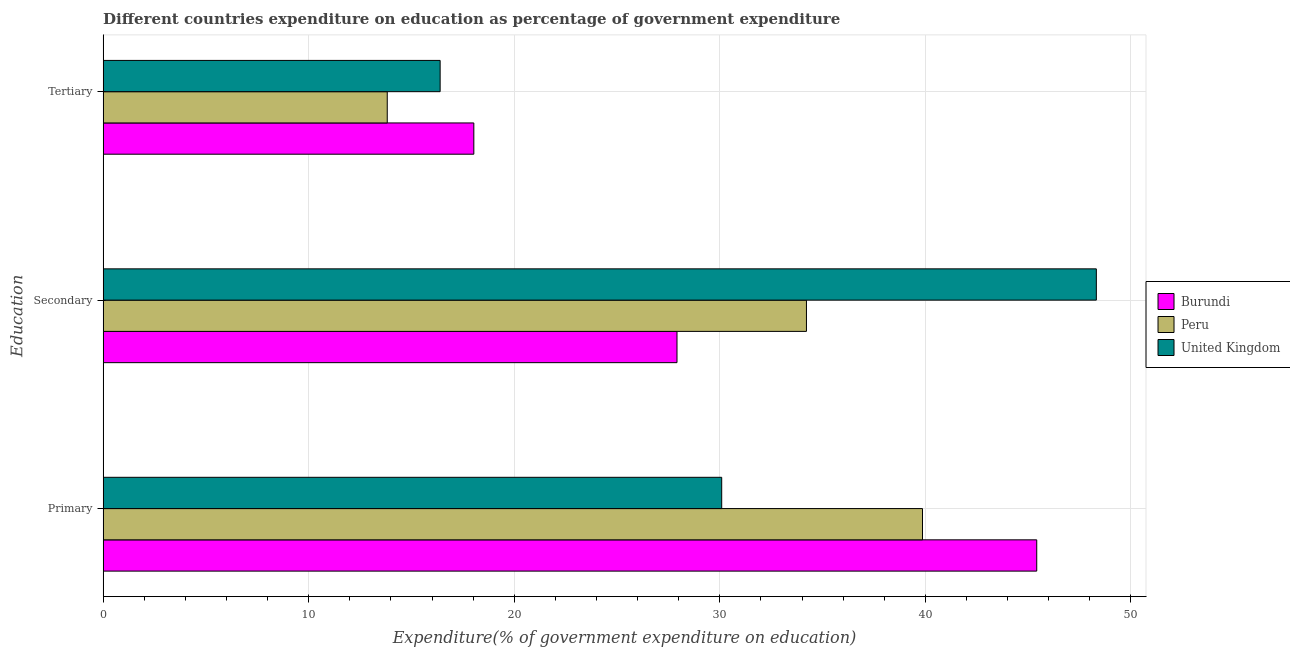How many groups of bars are there?
Your response must be concise. 3. How many bars are there on the 3rd tick from the top?
Ensure brevity in your answer.  3. What is the label of the 1st group of bars from the top?
Give a very brief answer. Tertiary. What is the expenditure on tertiary education in Burundi?
Keep it short and to the point. 18.03. Across all countries, what is the maximum expenditure on secondary education?
Your answer should be compact. 48.32. Across all countries, what is the minimum expenditure on tertiary education?
Offer a terse response. 13.82. In which country was the expenditure on primary education maximum?
Your answer should be compact. Burundi. What is the total expenditure on primary education in the graph?
Provide a succinct answer. 115.37. What is the difference between the expenditure on primary education in United Kingdom and that in Burundi?
Offer a very short reply. -15.33. What is the difference between the expenditure on secondary education in Burundi and the expenditure on primary education in Peru?
Provide a succinct answer. -11.94. What is the average expenditure on tertiary education per country?
Offer a terse response. 16.08. What is the difference between the expenditure on tertiary education and expenditure on secondary education in Burundi?
Your response must be concise. -9.88. What is the ratio of the expenditure on secondary education in Burundi to that in Peru?
Make the answer very short. 0.82. Is the expenditure on tertiary education in Burundi less than that in Peru?
Your response must be concise. No. What is the difference between the highest and the second highest expenditure on secondary education?
Offer a very short reply. 14.1. What is the difference between the highest and the lowest expenditure on primary education?
Your answer should be very brief. 15.33. What does the 1st bar from the top in Primary represents?
Offer a terse response. United Kingdom. Is it the case that in every country, the sum of the expenditure on primary education and expenditure on secondary education is greater than the expenditure on tertiary education?
Keep it short and to the point. Yes. How many bars are there?
Offer a terse response. 9. Are all the bars in the graph horizontal?
Give a very brief answer. Yes. How many countries are there in the graph?
Give a very brief answer. 3. Does the graph contain any zero values?
Make the answer very short. No. How are the legend labels stacked?
Ensure brevity in your answer.  Vertical. What is the title of the graph?
Offer a very short reply. Different countries expenditure on education as percentage of government expenditure. What is the label or title of the X-axis?
Your answer should be very brief. Expenditure(% of government expenditure on education). What is the label or title of the Y-axis?
Your answer should be very brief. Education. What is the Expenditure(% of government expenditure on education) of Burundi in Primary?
Your response must be concise. 45.42. What is the Expenditure(% of government expenditure on education) of Peru in Primary?
Your answer should be very brief. 39.86. What is the Expenditure(% of government expenditure on education) of United Kingdom in Primary?
Your answer should be very brief. 30.09. What is the Expenditure(% of government expenditure on education) in Burundi in Secondary?
Offer a terse response. 27.92. What is the Expenditure(% of government expenditure on education) in Peru in Secondary?
Offer a terse response. 34.22. What is the Expenditure(% of government expenditure on education) of United Kingdom in Secondary?
Make the answer very short. 48.32. What is the Expenditure(% of government expenditure on education) in Burundi in Tertiary?
Offer a very short reply. 18.03. What is the Expenditure(% of government expenditure on education) in Peru in Tertiary?
Give a very brief answer. 13.82. What is the Expenditure(% of government expenditure on education) of United Kingdom in Tertiary?
Provide a succinct answer. 16.39. Across all Education, what is the maximum Expenditure(% of government expenditure on education) in Burundi?
Your response must be concise. 45.42. Across all Education, what is the maximum Expenditure(% of government expenditure on education) in Peru?
Make the answer very short. 39.86. Across all Education, what is the maximum Expenditure(% of government expenditure on education) of United Kingdom?
Your answer should be compact. 48.32. Across all Education, what is the minimum Expenditure(% of government expenditure on education) of Burundi?
Provide a short and direct response. 18.03. Across all Education, what is the minimum Expenditure(% of government expenditure on education) of Peru?
Provide a short and direct response. 13.82. Across all Education, what is the minimum Expenditure(% of government expenditure on education) in United Kingdom?
Provide a succinct answer. 16.39. What is the total Expenditure(% of government expenditure on education) of Burundi in the graph?
Keep it short and to the point. 91.37. What is the total Expenditure(% of government expenditure on education) in Peru in the graph?
Provide a short and direct response. 87.9. What is the total Expenditure(% of government expenditure on education) in United Kingdom in the graph?
Give a very brief answer. 94.81. What is the difference between the Expenditure(% of government expenditure on education) in Burundi in Primary and that in Secondary?
Keep it short and to the point. 17.5. What is the difference between the Expenditure(% of government expenditure on education) of Peru in Primary and that in Secondary?
Offer a very short reply. 5.64. What is the difference between the Expenditure(% of government expenditure on education) in United Kingdom in Primary and that in Secondary?
Keep it short and to the point. -18.23. What is the difference between the Expenditure(% of government expenditure on education) in Burundi in Primary and that in Tertiary?
Your response must be concise. 27.38. What is the difference between the Expenditure(% of government expenditure on education) in Peru in Primary and that in Tertiary?
Make the answer very short. 26.04. What is the difference between the Expenditure(% of government expenditure on education) in United Kingdom in Primary and that in Tertiary?
Provide a short and direct response. 13.7. What is the difference between the Expenditure(% of government expenditure on education) of Burundi in Secondary and that in Tertiary?
Your response must be concise. 9.88. What is the difference between the Expenditure(% of government expenditure on education) of Peru in Secondary and that in Tertiary?
Ensure brevity in your answer.  20.39. What is the difference between the Expenditure(% of government expenditure on education) in United Kingdom in Secondary and that in Tertiary?
Offer a terse response. 31.92. What is the difference between the Expenditure(% of government expenditure on education) of Burundi in Primary and the Expenditure(% of government expenditure on education) of Peru in Secondary?
Make the answer very short. 11.2. What is the difference between the Expenditure(% of government expenditure on education) of Burundi in Primary and the Expenditure(% of government expenditure on education) of United Kingdom in Secondary?
Give a very brief answer. -2.9. What is the difference between the Expenditure(% of government expenditure on education) in Peru in Primary and the Expenditure(% of government expenditure on education) in United Kingdom in Secondary?
Make the answer very short. -8.46. What is the difference between the Expenditure(% of government expenditure on education) in Burundi in Primary and the Expenditure(% of government expenditure on education) in Peru in Tertiary?
Offer a very short reply. 31.6. What is the difference between the Expenditure(% of government expenditure on education) of Burundi in Primary and the Expenditure(% of government expenditure on education) of United Kingdom in Tertiary?
Offer a terse response. 29.02. What is the difference between the Expenditure(% of government expenditure on education) in Peru in Primary and the Expenditure(% of government expenditure on education) in United Kingdom in Tertiary?
Ensure brevity in your answer.  23.47. What is the difference between the Expenditure(% of government expenditure on education) in Burundi in Secondary and the Expenditure(% of government expenditure on education) in Peru in Tertiary?
Provide a succinct answer. 14.1. What is the difference between the Expenditure(% of government expenditure on education) of Burundi in Secondary and the Expenditure(% of government expenditure on education) of United Kingdom in Tertiary?
Keep it short and to the point. 11.52. What is the difference between the Expenditure(% of government expenditure on education) of Peru in Secondary and the Expenditure(% of government expenditure on education) of United Kingdom in Tertiary?
Give a very brief answer. 17.82. What is the average Expenditure(% of government expenditure on education) of Burundi per Education?
Your response must be concise. 30.46. What is the average Expenditure(% of government expenditure on education) of Peru per Education?
Offer a terse response. 29.3. What is the average Expenditure(% of government expenditure on education) in United Kingdom per Education?
Offer a very short reply. 31.6. What is the difference between the Expenditure(% of government expenditure on education) of Burundi and Expenditure(% of government expenditure on education) of Peru in Primary?
Keep it short and to the point. 5.56. What is the difference between the Expenditure(% of government expenditure on education) of Burundi and Expenditure(% of government expenditure on education) of United Kingdom in Primary?
Offer a very short reply. 15.33. What is the difference between the Expenditure(% of government expenditure on education) in Peru and Expenditure(% of government expenditure on education) in United Kingdom in Primary?
Offer a very short reply. 9.77. What is the difference between the Expenditure(% of government expenditure on education) of Burundi and Expenditure(% of government expenditure on education) of Peru in Secondary?
Ensure brevity in your answer.  -6.3. What is the difference between the Expenditure(% of government expenditure on education) of Burundi and Expenditure(% of government expenditure on education) of United Kingdom in Secondary?
Ensure brevity in your answer.  -20.4. What is the difference between the Expenditure(% of government expenditure on education) in Peru and Expenditure(% of government expenditure on education) in United Kingdom in Secondary?
Your answer should be compact. -14.1. What is the difference between the Expenditure(% of government expenditure on education) in Burundi and Expenditure(% of government expenditure on education) in Peru in Tertiary?
Ensure brevity in your answer.  4.21. What is the difference between the Expenditure(% of government expenditure on education) of Burundi and Expenditure(% of government expenditure on education) of United Kingdom in Tertiary?
Make the answer very short. 1.64. What is the difference between the Expenditure(% of government expenditure on education) of Peru and Expenditure(% of government expenditure on education) of United Kingdom in Tertiary?
Give a very brief answer. -2.57. What is the ratio of the Expenditure(% of government expenditure on education) of Burundi in Primary to that in Secondary?
Your answer should be compact. 1.63. What is the ratio of the Expenditure(% of government expenditure on education) in Peru in Primary to that in Secondary?
Provide a succinct answer. 1.17. What is the ratio of the Expenditure(% of government expenditure on education) in United Kingdom in Primary to that in Secondary?
Your answer should be compact. 0.62. What is the ratio of the Expenditure(% of government expenditure on education) in Burundi in Primary to that in Tertiary?
Your answer should be compact. 2.52. What is the ratio of the Expenditure(% of government expenditure on education) of Peru in Primary to that in Tertiary?
Your answer should be compact. 2.88. What is the ratio of the Expenditure(% of government expenditure on education) of United Kingdom in Primary to that in Tertiary?
Keep it short and to the point. 1.84. What is the ratio of the Expenditure(% of government expenditure on education) in Burundi in Secondary to that in Tertiary?
Give a very brief answer. 1.55. What is the ratio of the Expenditure(% of government expenditure on education) of Peru in Secondary to that in Tertiary?
Give a very brief answer. 2.48. What is the ratio of the Expenditure(% of government expenditure on education) in United Kingdom in Secondary to that in Tertiary?
Offer a terse response. 2.95. What is the difference between the highest and the second highest Expenditure(% of government expenditure on education) of Burundi?
Make the answer very short. 17.5. What is the difference between the highest and the second highest Expenditure(% of government expenditure on education) in Peru?
Your answer should be very brief. 5.64. What is the difference between the highest and the second highest Expenditure(% of government expenditure on education) in United Kingdom?
Your response must be concise. 18.23. What is the difference between the highest and the lowest Expenditure(% of government expenditure on education) of Burundi?
Your answer should be very brief. 27.38. What is the difference between the highest and the lowest Expenditure(% of government expenditure on education) in Peru?
Make the answer very short. 26.04. What is the difference between the highest and the lowest Expenditure(% of government expenditure on education) of United Kingdom?
Provide a succinct answer. 31.92. 